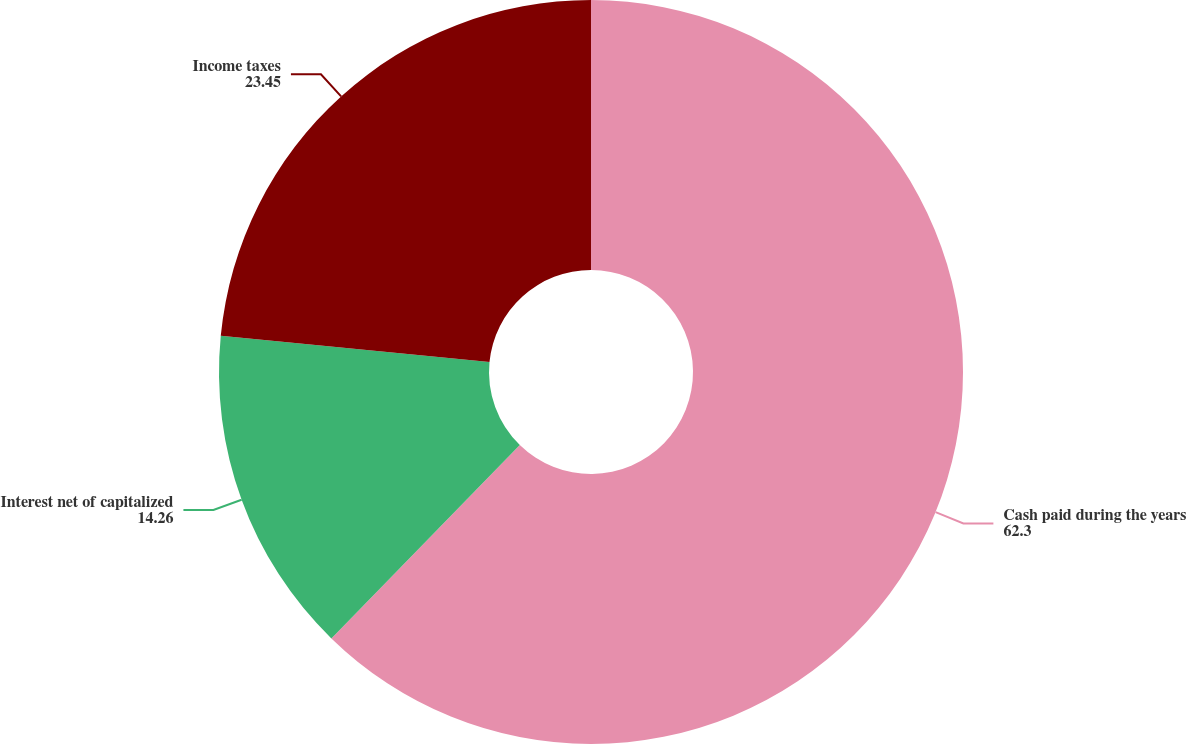Convert chart. <chart><loc_0><loc_0><loc_500><loc_500><pie_chart><fcel>Cash paid during the years<fcel>Interest net of capitalized<fcel>Income taxes<nl><fcel>62.3%<fcel>14.26%<fcel>23.45%<nl></chart> 